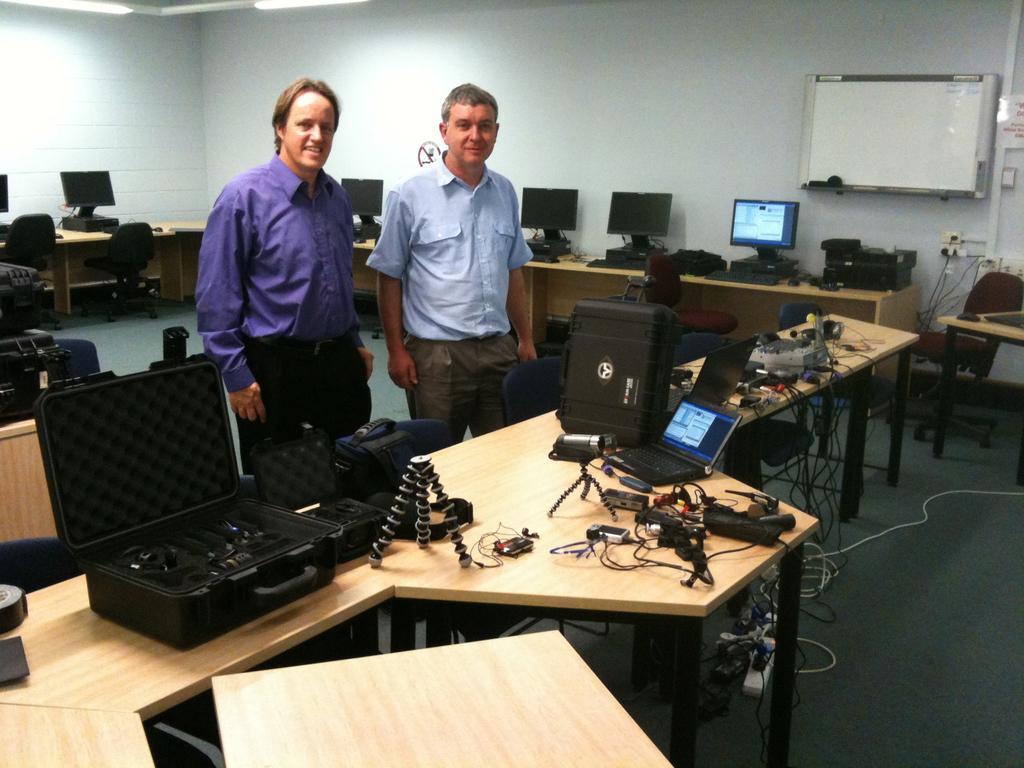Could you give a brief overview of what you see in this image? In this picture two men are standing behind the table , there are many electronic gadgets on the table and empty chairs. 